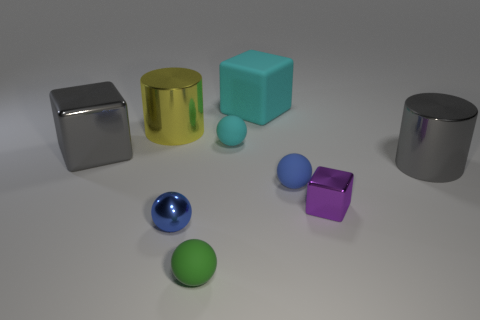Is there a cyan ball of the same size as the green matte object?
Provide a succinct answer. Yes. There is a small object that is behind the metallic cylinder that is to the right of the blue thing right of the tiny metal sphere; what is its shape?
Ensure brevity in your answer.  Sphere. Are there more shiny cubes that are on the right side of the matte cube than small brown metal things?
Make the answer very short. Yes. Are there any other large objects that have the same shape as the blue rubber object?
Provide a succinct answer. No. Are the big cyan object and the ball on the right side of the tiny cyan thing made of the same material?
Your answer should be very brief. Yes. The small shiny ball is what color?
Keep it short and to the point. Blue. How many small objects are in front of the gray object that is right of the small metallic object that is right of the big cyan rubber cube?
Provide a short and direct response. 4. There is a green ball; are there any rubber spheres on the right side of it?
Your answer should be compact. Yes. How many tiny blocks are made of the same material as the small purple object?
Ensure brevity in your answer.  0. How many objects are either small metallic cylinders or cyan objects?
Your answer should be compact. 2. 